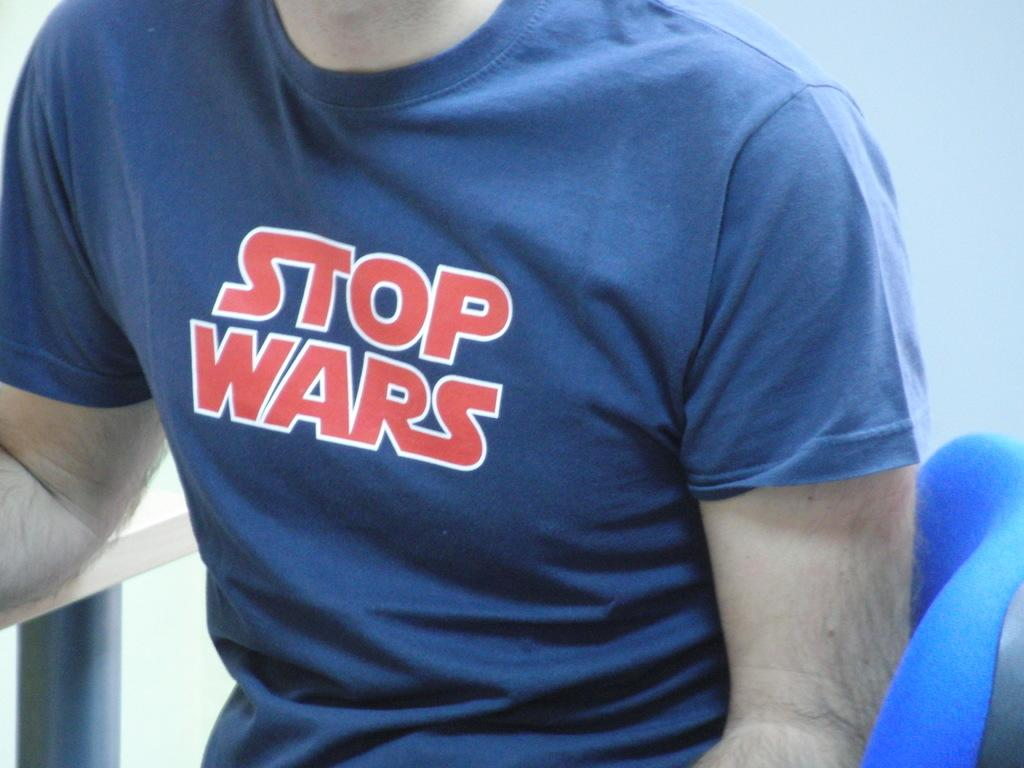<image>
Create a compact narrative representing the image presented. A male wearing a blue shirt that says stop wars. 